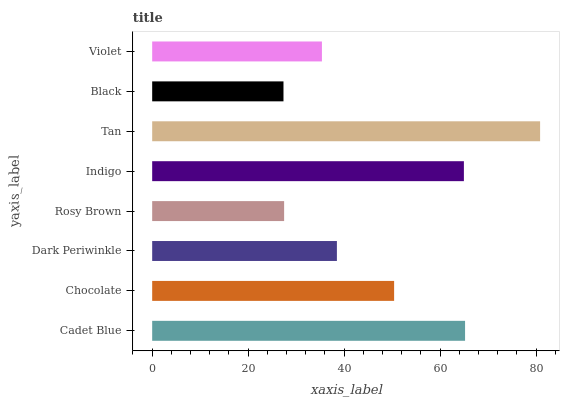Is Black the minimum?
Answer yes or no. Yes. Is Tan the maximum?
Answer yes or no. Yes. Is Chocolate the minimum?
Answer yes or no. No. Is Chocolate the maximum?
Answer yes or no. No. Is Cadet Blue greater than Chocolate?
Answer yes or no. Yes. Is Chocolate less than Cadet Blue?
Answer yes or no. Yes. Is Chocolate greater than Cadet Blue?
Answer yes or no. No. Is Cadet Blue less than Chocolate?
Answer yes or no. No. Is Chocolate the high median?
Answer yes or no. Yes. Is Dark Periwinkle the low median?
Answer yes or no. Yes. Is Violet the high median?
Answer yes or no. No. Is Indigo the low median?
Answer yes or no. No. 